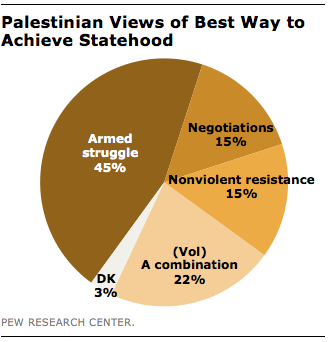Identify some key points in this picture. The difference between the highest and lowest value is 42. The pie chart shows that armed struggle has the highest value among the different methods of conflict resolution. 